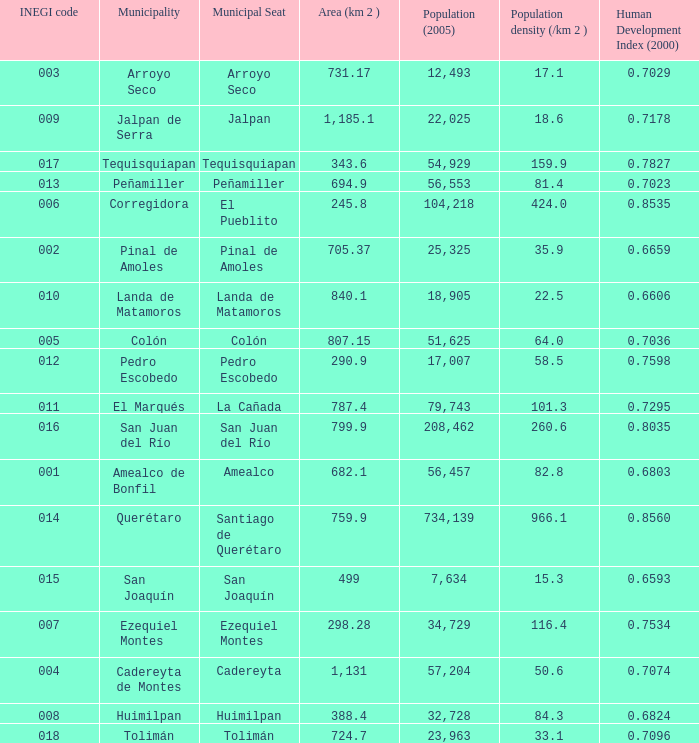WHich INEGI code has a Population density (/km 2 ) smaller than 81.4 and 0.6593 Human Development Index (2000)? 15.0. 